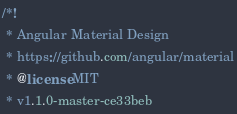<code> <loc_0><loc_0><loc_500><loc_500><_CSS_>/*!
 * Angular Material Design
 * https://github.com/angular/material
 * @license MIT
 * v1.1.0-master-ce33beb</code> 